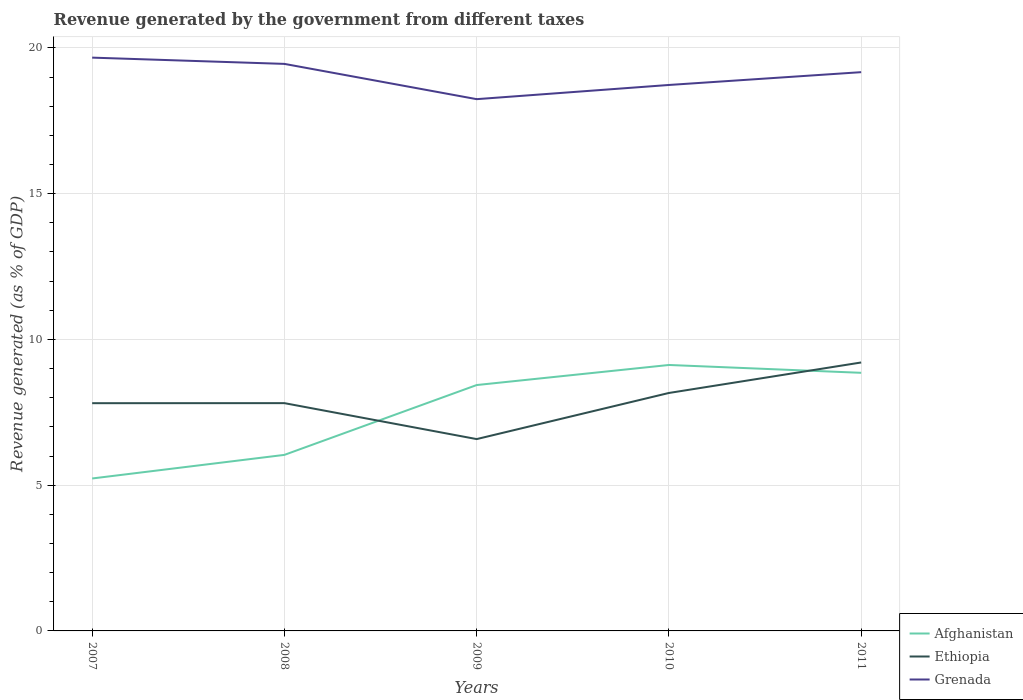Across all years, what is the maximum revenue generated by the government in Afghanistan?
Offer a very short reply. 5.23. What is the total revenue generated by the government in Ethiopia in the graph?
Your answer should be compact. 1.23. What is the difference between the highest and the second highest revenue generated by the government in Ethiopia?
Your answer should be compact. 2.63. How many lines are there?
Make the answer very short. 3. What is the difference between two consecutive major ticks on the Y-axis?
Your answer should be very brief. 5. Are the values on the major ticks of Y-axis written in scientific E-notation?
Your answer should be very brief. No. Where does the legend appear in the graph?
Offer a very short reply. Bottom right. How many legend labels are there?
Make the answer very short. 3. How are the legend labels stacked?
Offer a very short reply. Vertical. What is the title of the graph?
Offer a terse response. Revenue generated by the government from different taxes. What is the label or title of the Y-axis?
Your answer should be compact. Revenue generated (as % of GDP). What is the Revenue generated (as % of GDP) of Afghanistan in 2007?
Your response must be concise. 5.23. What is the Revenue generated (as % of GDP) of Ethiopia in 2007?
Offer a very short reply. 7.81. What is the Revenue generated (as % of GDP) of Grenada in 2007?
Give a very brief answer. 19.67. What is the Revenue generated (as % of GDP) in Afghanistan in 2008?
Provide a succinct answer. 6.04. What is the Revenue generated (as % of GDP) of Ethiopia in 2008?
Your answer should be compact. 7.81. What is the Revenue generated (as % of GDP) of Grenada in 2008?
Offer a very short reply. 19.45. What is the Revenue generated (as % of GDP) of Afghanistan in 2009?
Offer a very short reply. 8.43. What is the Revenue generated (as % of GDP) in Ethiopia in 2009?
Offer a terse response. 6.58. What is the Revenue generated (as % of GDP) of Grenada in 2009?
Ensure brevity in your answer.  18.24. What is the Revenue generated (as % of GDP) of Afghanistan in 2010?
Keep it short and to the point. 9.12. What is the Revenue generated (as % of GDP) of Ethiopia in 2010?
Give a very brief answer. 8.16. What is the Revenue generated (as % of GDP) of Grenada in 2010?
Offer a terse response. 18.73. What is the Revenue generated (as % of GDP) of Afghanistan in 2011?
Your answer should be very brief. 8.85. What is the Revenue generated (as % of GDP) of Ethiopia in 2011?
Ensure brevity in your answer.  9.21. What is the Revenue generated (as % of GDP) in Grenada in 2011?
Your answer should be very brief. 19.17. Across all years, what is the maximum Revenue generated (as % of GDP) of Afghanistan?
Offer a very short reply. 9.12. Across all years, what is the maximum Revenue generated (as % of GDP) in Ethiopia?
Provide a short and direct response. 9.21. Across all years, what is the maximum Revenue generated (as % of GDP) of Grenada?
Your answer should be very brief. 19.67. Across all years, what is the minimum Revenue generated (as % of GDP) of Afghanistan?
Provide a short and direct response. 5.23. Across all years, what is the minimum Revenue generated (as % of GDP) in Ethiopia?
Offer a very short reply. 6.58. Across all years, what is the minimum Revenue generated (as % of GDP) of Grenada?
Give a very brief answer. 18.24. What is the total Revenue generated (as % of GDP) in Afghanistan in the graph?
Offer a very short reply. 37.68. What is the total Revenue generated (as % of GDP) in Ethiopia in the graph?
Your answer should be very brief. 39.58. What is the total Revenue generated (as % of GDP) of Grenada in the graph?
Provide a short and direct response. 95.26. What is the difference between the Revenue generated (as % of GDP) in Afghanistan in 2007 and that in 2008?
Provide a short and direct response. -0.81. What is the difference between the Revenue generated (as % of GDP) in Ethiopia in 2007 and that in 2008?
Your response must be concise. -0. What is the difference between the Revenue generated (as % of GDP) in Grenada in 2007 and that in 2008?
Your answer should be compact. 0.22. What is the difference between the Revenue generated (as % of GDP) of Afghanistan in 2007 and that in 2009?
Offer a terse response. -3.21. What is the difference between the Revenue generated (as % of GDP) of Ethiopia in 2007 and that in 2009?
Offer a terse response. 1.23. What is the difference between the Revenue generated (as % of GDP) in Grenada in 2007 and that in 2009?
Your answer should be very brief. 1.43. What is the difference between the Revenue generated (as % of GDP) in Afghanistan in 2007 and that in 2010?
Provide a short and direct response. -3.89. What is the difference between the Revenue generated (as % of GDP) in Ethiopia in 2007 and that in 2010?
Make the answer very short. -0.35. What is the difference between the Revenue generated (as % of GDP) in Grenada in 2007 and that in 2010?
Offer a terse response. 0.94. What is the difference between the Revenue generated (as % of GDP) in Afghanistan in 2007 and that in 2011?
Keep it short and to the point. -3.62. What is the difference between the Revenue generated (as % of GDP) of Ethiopia in 2007 and that in 2011?
Ensure brevity in your answer.  -1.4. What is the difference between the Revenue generated (as % of GDP) in Grenada in 2007 and that in 2011?
Offer a very short reply. 0.5. What is the difference between the Revenue generated (as % of GDP) of Afghanistan in 2008 and that in 2009?
Give a very brief answer. -2.4. What is the difference between the Revenue generated (as % of GDP) in Ethiopia in 2008 and that in 2009?
Provide a short and direct response. 1.23. What is the difference between the Revenue generated (as % of GDP) of Grenada in 2008 and that in 2009?
Provide a succinct answer. 1.21. What is the difference between the Revenue generated (as % of GDP) in Afghanistan in 2008 and that in 2010?
Keep it short and to the point. -3.08. What is the difference between the Revenue generated (as % of GDP) of Ethiopia in 2008 and that in 2010?
Offer a very short reply. -0.35. What is the difference between the Revenue generated (as % of GDP) of Grenada in 2008 and that in 2010?
Your answer should be compact. 0.72. What is the difference between the Revenue generated (as % of GDP) of Afghanistan in 2008 and that in 2011?
Your answer should be very brief. -2.82. What is the difference between the Revenue generated (as % of GDP) in Ethiopia in 2008 and that in 2011?
Provide a short and direct response. -1.4. What is the difference between the Revenue generated (as % of GDP) of Grenada in 2008 and that in 2011?
Provide a succinct answer. 0.28. What is the difference between the Revenue generated (as % of GDP) in Afghanistan in 2009 and that in 2010?
Offer a very short reply. -0.69. What is the difference between the Revenue generated (as % of GDP) in Ethiopia in 2009 and that in 2010?
Your response must be concise. -1.58. What is the difference between the Revenue generated (as % of GDP) of Grenada in 2009 and that in 2010?
Make the answer very short. -0.49. What is the difference between the Revenue generated (as % of GDP) of Afghanistan in 2009 and that in 2011?
Your answer should be very brief. -0.42. What is the difference between the Revenue generated (as % of GDP) in Ethiopia in 2009 and that in 2011?
Offer a very short reply. -2.63. What is the difference between the Revenue generated (as % of GDP) of Grenada in 2009 and that in 2011?
Your answer should be very brief. -0.93. What is the difference between the Revenue generated (as % of GDP) in Afghanistan in 2010 and that in 2011?
Your answer should be very brief. 0.27. What is the difference between the Revenue generated (as % of GDP) of Ethiopia in 2010 and that in 2011?
Provide a succinct answer. -1.05. What is the difference between the Revenue generated (as % of GDP) in Grenada in 2010 and that in 2011?
Your answer should be very brief. -0.44. What is the difference between the Revenue generated (as % of GDP) of Afghanistan in 2007 and the Revenue generated (as % of GDP) of Ethiopia in 2008?
Keep it short and to the point. -2.58. What is the difference between the Revenue generated (as % of GDP) of Afghanistan in 2007 and the Revenue generated (as % of GDP) of Grenada in 2008?
Offer a terse response. -14.22. What is the difference between the Revenue generated (as % of GDP) in Ethiopia in 2007 and the Revenue generated (as % of GDP) in Grenada in 2008?
Offer a terse response. -11.64. What is the difference between the Revenue generated (as % of GDP) in Afghanistan in 2007 and the Revenue generated (as % of GDP) in Ethiopia in 2009?
Offer a terse response. -1.35. What is the difference between the Revenue generated (as % of GDP) of Afghanistan in 2007 and the Revenue generated (as % of GDP) of Grenada in 2009?
Your answer should be compact. -13.01. What is the difference between the Revenue generated (as % of GDP) of Ethiopia in 2007 and the Revenue generated (as % of GDP) of Grenada in 2009?
Give a very brief answer. -10.43. What is the difference between the Revenue generated (as % of GDP) in Afghanistan in 2007 and the Revenue generated (as % of GDP) in Ethiopia in 2010?
Ensure brevity in your answer.  -2.93. What is the difference between the Revenue generated (as % of GDP) in Afghanistan in 2007 and the Revenue generated (as % of GDP) in Grenada in 2010?
Your response must be concise. -13.5. What is the difference between the Revenue generated (as % of GDP) of Ethiopia in 2007 and the Revenue generated (as % of GDP) of Grenada in 2010?
Ensure brevity in your answer.  -10.92. What is the difference between the Revenue generated (as % of GDP) in Afghanistan in 2007 and the Revenue generated (as % of GDP) in Ethiopia in 2011?
Ensure brevity in your answer.  -3.98. What is the difference between the Revenue generated (as % of GDP) of Afghanistan in 2007 and the Revenue generated (as % of GDP) of Grenada in 2011?
Offer a very short reply. -13.94. What is the difference between the Revenue generated (as % of GDP) in Ethiopia in 2007 and the Revenue generated (as % of GDP) in Grenada in 2011?
Your answer should be very brief. -11.36. What is the difference between the Revenue generated (as % of GDP) in Afghanistan in 2008 and the Revenue generated (as % of GDP) in Ethiopia in 2009?
Make the answer very short. -0.54. What is the difference between the Revenue generated (as % of GDP) of Afghanistan in 2008 and the Revenue generated (as % of GDP) of Grenada in 2009?
Make the answer very short. -12.2. What is the difference between the Revenue generated (as % of GDP) in Ethiopia in 2008 and the Revenue generated (as % of GDP) in Grenada in 2009?
Give a very brief answer. -10.43. What is the difference between the Revenue generated (as % of GDP) in Afghanistan in 2008 and the Revenue generated (as % of GDP) in Ethiopia in 2010?
Offer a terse response. -2.12. What is the difference between the Revenue generated (as % of GDP) of Afghanistan in 2008 and the Revenue generated (as % of GDP) of Grenada in 2010?
Keep it short and to the point. -12.69. What is the difference between the Revenue generated (as % of GDP) of Ethiopia in 2008 and the Revenue generated (as % of GDP) of Grenada in 2010?
Provide a succinct answer. -10.92. What is the difference between the Revenue generated (as % of GDP) in Afghanistan in 2008 and the Revenue generated (as % of GDP) in Ethiopia in 2011?
Keep it short and to the point. -3.17. What is the difference between the Revenue generated (as % of GDP) of Afghanistan in 2008 and the Revenue generated (as % of GDP) of Grenada in 2011?
Ensure brevity in your answer.  -13.13. What is the difference between the Revenue generated (as % of GDP) in Ethiopia in 2008 and the Revenue generated (as % of GDP) in Grenada in 2011?
Your response must be concise. -11.35. What is the difference between the Revenue generated (as % of GDP) in Afghanistan in 2009 and the Revenue generated (as % of GDP) in Ethiopia in 2010?
Provide a short and direct response. 0.27. What is the difference between the Revenue generated (as % of GDP) of Afghanistan in 2009 and the Revenue generated (as % of GDP) of Grenada in 2010?
Make the answer very short. -10.29. What is the difference between the Revenue generated (as % of GDP) of Ethiopia in 2009 and the Revenue generated (as % of GDP) of Grenada in 2010?
Provide a succinct answer. -12.15. What is the difference between the Revenue generated (as % of GDP) in Afghanistan in 2009 and the Revenue generated (as % of GDP) in Ethiopia in 2011?
Ensure brevity in your answer.  -0.77. What is the difference between the Revenue generated (as % of GDP) of Afghanistan in 2009 and the Revenue generated (as % of GDP) of Grenada in 2011?
Offer a very short reply. -10.73. What is the difference between the Revenue generated (as % of GDP) of Ethiopia in 2009 and the Revenue generated (as % of GDP) of Grenada in 2011?
Make the answer very short. -12.59. What is the difference between the Revenue generated (as % of GDP) in Afghanistan in 2010 and the Revenue generated (as % of GDP) in Ethiopia in 2011?
Your answer should be compact. -0.09. What is the difference between the Revenue generated (as % of GDP) of Afghanistan in 2010 and the Revenue generated (as % of GDP) of Grenada in 2011?
Give a very brief answer. -10.05. What is the difference between the Revenue generated (as % of GDP) in Ethiopia in 2010 and the Revenue generated (as % of GDP) in Grenada in 2011?
Offer a very short reply. -11.01. What is the average Revenue generated (as % of GDP) in Afghanistan per year?
Offer a very short reply. 7.54. What is the average Revenue generated (as % of GDP) of Ethiopia per year?
Keep it short and to the point. 7.92. What is the average Revenue generated (as % of GDP) of Grenada per year?
Give a very brief answer. 19.05. In the year 2007, what is the difference between the Revenue generated (as % of GDP) in Afghanistan and Revenue generated (as % of GDP) in Ethiopia?
Provide a short and direct response. -2.58. In the year 2007, what is the difference between the Revenue generated (as % of GDP) in Afghanistan and Revenue generated (as % of GDP) in Grenada?
Your answer should be very brief. -14.44. In the year 2007, what is the difference between the Revenue generated (as % of GDP) of Ethiopia and Revenue generated (as % of GDP) of Grenada?
Ensure brevity in your answer.  -11.86. In the year 2008, what is the difference between the Revenue generated (as % of GDP) of Afghanistan and Revenue generated (as % of GDP) of Ethiopia?
Your answer should be very brief. -1.77. In the year 2008, what is the difference between the Revenue generated (as % of GDP) of Afghanistan and Revenue generated (as % of GDP) of Grenada?
Your answer should be compact. -13.41. In the year 2008, what is the difference between the Revenue generated (as % of GDP) of Ethiopia and Revenue generated (as % of GDP) of Grenada?
Your answer should be compact. -11.64. In the year 2009, what is the difference between the Revenue generated (as % of GDP) of Afghanistan and Revenue generated (as % of GDP) of Ethiopia?
Ensure brevity in your answer.  1.85. In the year 2009, what is the difference between the Revenue generated (as % of GDP) of Afghanistan and Revenue generated (as % of GDP) of Grenada?
Keep it short and to the point. -9.81. In the year 2009, what is the difference between the Revenue generated (as % of GDP) of Ethiopia and Revenue generated (as % of GDP) of Grenada?
Your response must be concise. -11.66. In the year 2010, what is the difference between the Revenue generated (as % of GDP) in Afghanistan and Revenue generated (as % of GDP) in Ethiopia?
Your answer should be very brief. 0.96. In the year 2010, what is the difference between the Revenue generated (as % of GDP) of Afghanistan and Revenue generated (as % of GDP) of Grenada?
Your answer should be very brief. -9.61. In the year 2010, what is the difference between the Revenue generated (as % of GDP) in Ethiopia and Revenue generated (as % of GDP) in Grenada?
Offer a terse response. -10.57. In the year 2011, what is the difference between the Revenue generated (as % of GDP) of Afghanistan and Revenue generated (as % of GDP) of Ethiopia?
Your response must be concise. -0.35. In the year 2011, what is the difference between the Revenue generated (as % of GDP) in Afghanistan and Revenue generated (as % of GDP) in Grenada?
Give a very brief answer. -10.31. In the year 2011, what is the difference between the Revenue generated (as % of GDP) of Ethiopia and Revenue generated (as % of GDP) of Grenada?
Offer a very short reply. -9.96. What is the ratio of the Revenue generated (as % of GDP) of Afghanistan in 2007 to that in 2008?
Provide a succinct answer. 0.87. What is the ratio of the Revenue generated (as % of GDP) in Ethiopia in 2007 to that in 2008?
Keep it short and to the point. 1. What is the ratio of the Revenue generated (as % of GDP) of Grenada in 2007 to that in 2008?
Offer a terse response. 1.01. What is the ratio of the Revenue generated (as % of GDP) in Afghanistan in 2007 to that in 2009?
Ensure brevity in your answer.  0.62. What is the ratio of the Revenue generated (as % of GDP) of Ethiopia in 2007 to that in 2009?
Give a very brief answer. 1.19. What is the ratio of the Revenue generated (as % of GDP) in Grenada in 2007 to that in 2009?
Your answer should be compact. 1.08. What is the ratio of the Revenue generated (as % of GDP) in Afghanistan in 2007 to that in 2010?
Make the answer very short. 0.57. What is the ratio of the Revenue generated (as % of GDP) of Ethiopia in 2007 to that in 2010?
Make the answer very short. 0.96. What is the ratio of the Revenue generated (as % of GDP) of Grenada in 2007 to that in 2010?
Keep it short and to the point. 1.05. What is the ratio of the Revenue generated (as % of GDP) of Afghanistan in 2007 to that in 2011?
Give a very brief answer. 0.59. What is the ratio of the Revenue generated (as % of GDP) of Ethiopia in 2007 to that in 2011?
Your answer should be very brief. 0.85. What is the ratio of the Revenue generated (as % of GDP) of Grenada in 2007 to that in 2011?
Provide a short and direct response. 1.03. What is the ratio of the Revenue generated (as % of GDP) in Afghanistan in 2008 to that in 2009?
Keep it short and to the point. 0.72. What is the ratio of the Revenue generated (as % of GDP) in Ethiopia in 2008 to that in 2009?
Offer a terse response. 1.19. What is the ratio of the Revenue generated (as % of GDP) of Grenada in 2008 to that in 2009?
Provide a succinct answer. 1.07. What is the ratio of the Revenue generated (as % of GDP) in Afghanistan in 2008 to that in 2010?
Make the answer very short. 0.66. What is the ratio of the Revenue generated (as % of GDP) of Ethiopia in 2008 to that in 2010?
Provide a succinct answer. 0.96. What is the ratio of the Revenue generated (as % of GDP) in Grenada in 2008 to that in 2010?
Offer a terse response. 1.04. What is the ratio of the Revenue generated (as % of GDP) of Afghanistan in 2008 to that in 2011?
Make the answer very short. 0.68. What is the ratio of the Revenue generated (as % of GDP) in Ethiopia in 2008 to that in 2011?
Offer a terse response. 0.85. What is the ratio of the Revenue generated (as % of GDP) in Grenada in 2008 to that in 2011?
Keep it short and to the point. 1.01. What is the ratio of the Revenue generated (as % of GDP) of Afghanistan in 2009 to that in 2010?
Give a very brief answer. 0.92. What is the ratio of the Revenue generated (as % of GDP) of Ethiopia in 2009 to that in 2010?
Your answer should be very brief. 0.81. What is the ratio of the Revenue generated (as % of GDP) of Grenada in 2009 to that in 2010?
Make the answer very short. 0.97. What is the ratio of the Revenue generated (as % of GDP) of Afghanistan in 2009 to that in 2011?
Offer a very short reply. 0.95. What is the ratio of the Revenue generated (as % of GDP) of Ethiopia in 2009 to that in 2011?
Make the answer very short. 0.71. What is the ratio of the Revenue generated (as % of GDP) in Grenada in 2009 to that in 2011?
Keep it short and to the point. 0.95. What is the ratio of the Revenue generated (as % of GDP) in Afghanistan in 2010 to that in 2011?
Keep it short and to the point. 1.03. What is the ratio of the Revenue generated (as % of GDP) in Ethiopia in 2010 to that in 2011?
Provide a short and direct response. 0.89. What is the ratio of the Revenue generated (as % of GDP) of Grenada in 2010 to that in 2011?
Your response must be concise. 0.98. What is the difference between the highest and the second highest Revenue generated (as % of GDP) of Afghanistan?
Your answer should be compact. 0.27. What is the difference between the highest and the second highest Revenue generated (as % of GDP) of Ethiopia?
Provide a short and direct response. 1.05. What is the difference between the highest and the second highest Revenue generated (as % of GDP) in Grenada?
Provide a succinct answer. 0.22. What is the difference between the highest and the lowest Revenue generated (as % of GDP) of Afghanistan?
Provide a succinct answer. 3.89. What is the difference between the highest and the lowest Revenue generated (as % of GDP) in Ethiopia?
Your answer should be very brief. 2.63. What is the difference between the highest and the lowest Revenue generated (as % of GDP) of Grenada?
Provide a succinct answer. 1.43. 